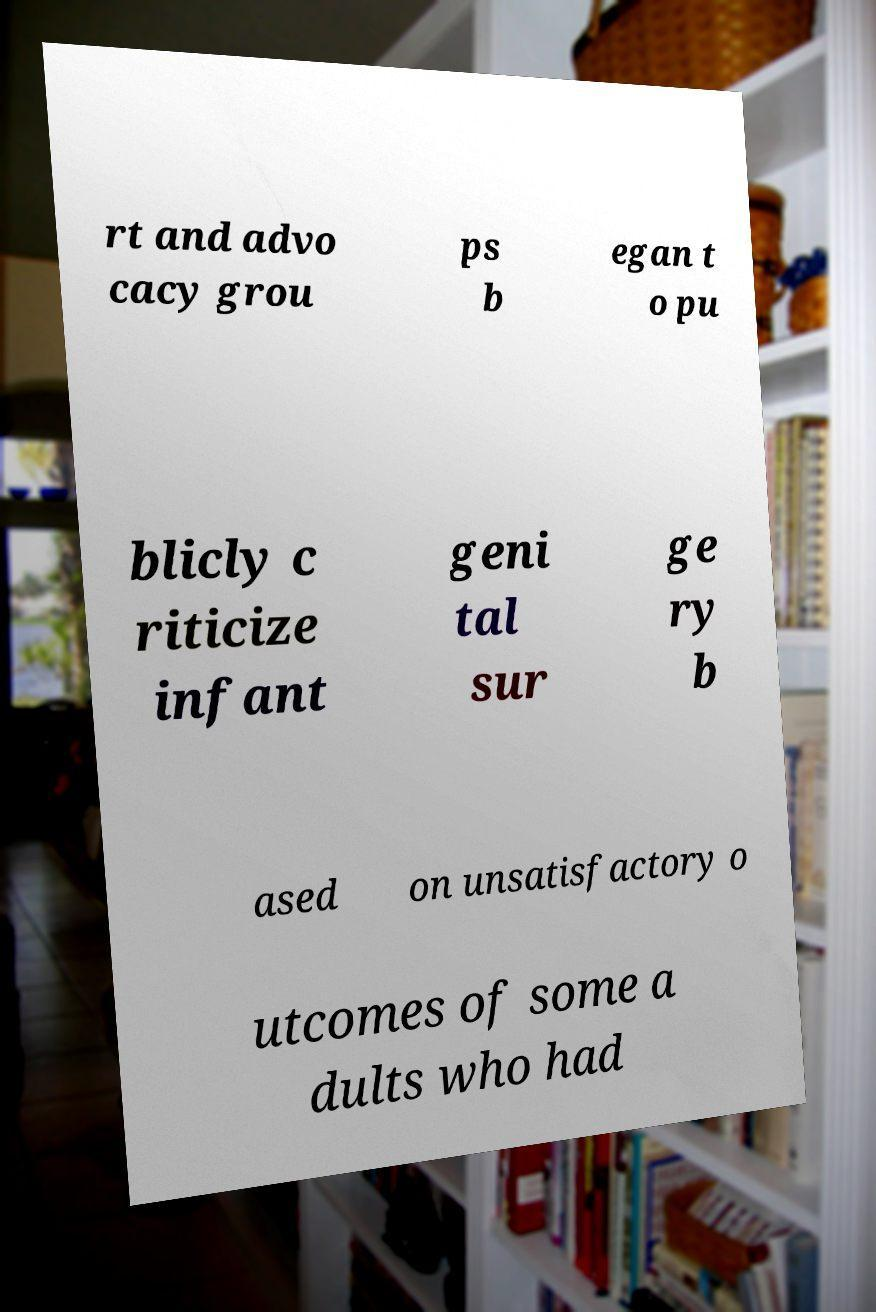Please identify and transcribe the text found in this image. rt and advo cacy grou ps b egan t o pu blicly c riticize infant geni tal sur ge ry b ased on unsatisfactory o utcomes of some a dults who had 